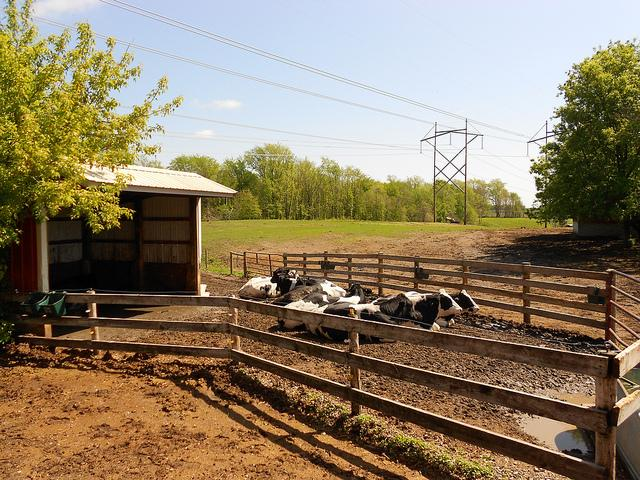What is the large structure in the background? barn 